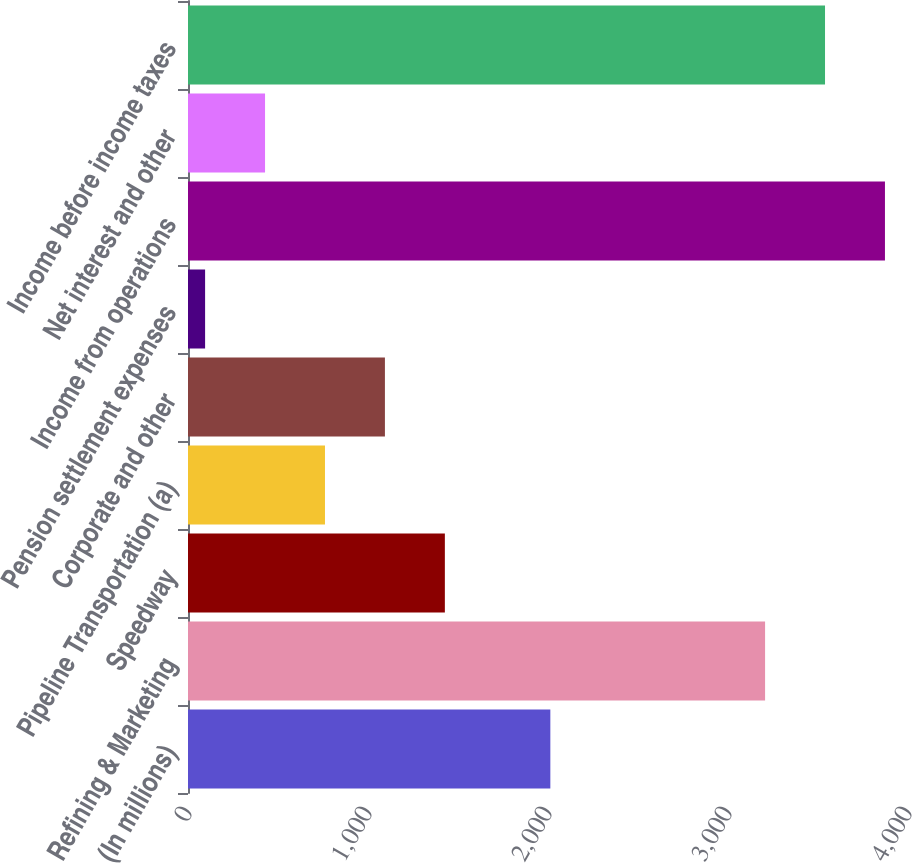<chart> <loc_0><loc_0><loc_500><loc_500><bar_chart><fcel>(In millions)<fcel>Refining & Marketing<fcel>Speedway<fcel>Pipeline Transportation (a)<fcel>Corporate and other<fcel>Pension settlement expenses<fcel>Income from operations<fcel>Net interest and other<fcel>Income before income taxes<nl><fcel>2013<fcel>3206<fcel>1427<fcel>761<fcel>1094<fcel>95<fcel>3872<fcel>428<fcel>3539<nl></chart> 